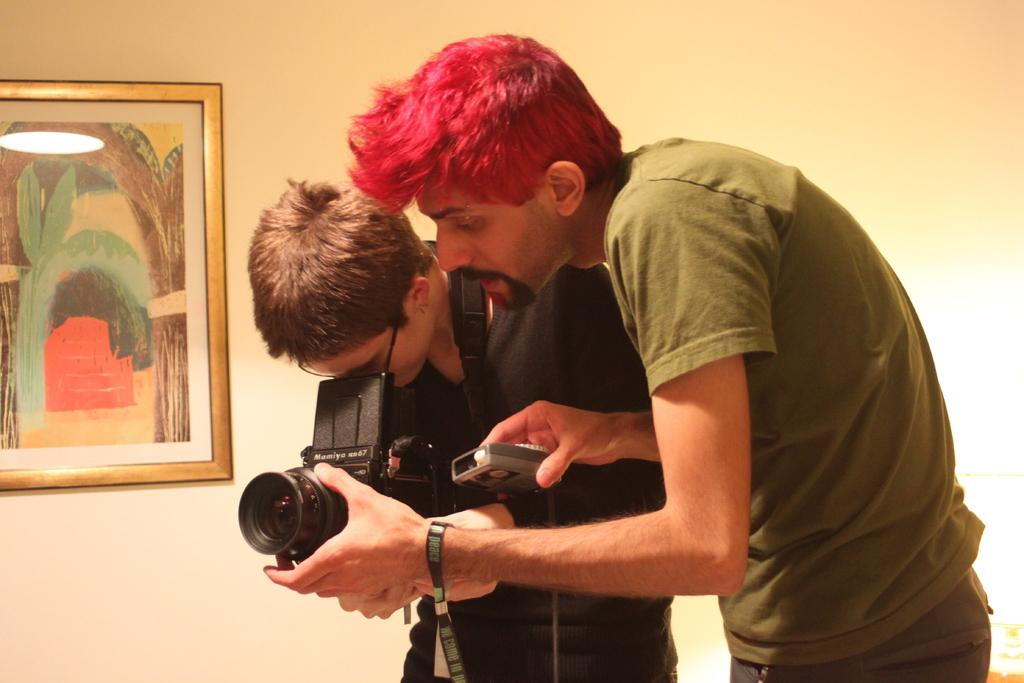What is the person in the image doing? There is a person looking into the camera in the image. Who is holding the camera in the image? There is another person holding the camera in the image. Can you describe the appearance of the person holding the camera? The person holding the camera has red hair and is wearing a green t-shirt. What can be seen on the left side of the image? There is a photograph on the wall on the left side of the image. What type of vase is present on the right side of the image? There is no vase present on the right side of the image. Can you describe the drum that the person is playing in the image? There is no drum present in the image; the person is holding a camera. 